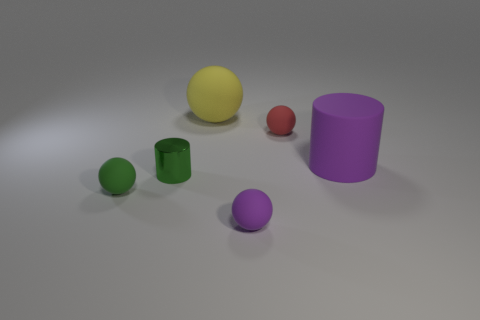There is a purple thing that is behind the small rubber sphere that is to the left of the big matte thing that is behind the purple matte cylinder; what is its size? The purple object in question, which appears behind the small rubber sphere and to the left of the large matte object which is behind the purple matte cylinder, can be classified as medium-sized when compared to the other objects present in the image. 